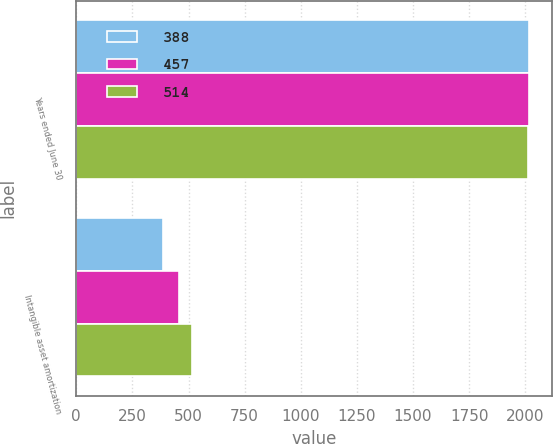Convert chart. <chart><loc_0><loc_0><loc_500><loc_500><stacked_bar_chart><ecel><fcel>Years ended June 30<fcel>Intangible asset amortization<nl><fcel>388<fcel>2016<fcel>388<nl><fcel>457<fcel>2015<fcel>457<nl><fcel>514<fcel>2014<fcel>514<nl></chart> 